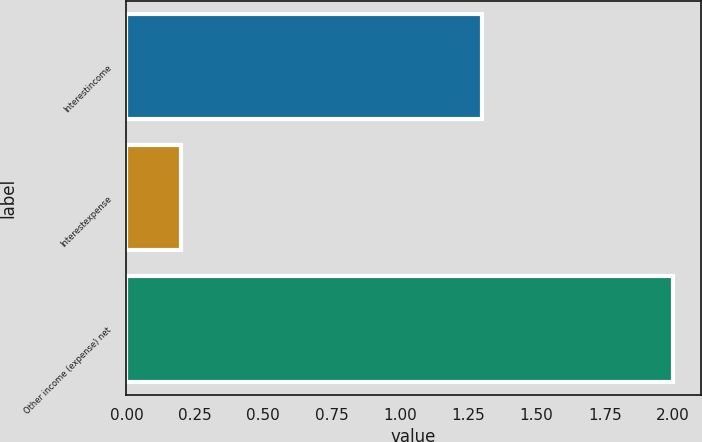Convert chart to OTSL. <chart><loc_0><loc_0><loc_500><loc_500><bar_chart><fcel>Interestincome<fcel>Interestexpense<fcel>Other income (expense) net<nl><fcel>1.3<fcel>0.2<fcel>2<nl></chart> 